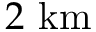<formula> <loc_0><loc_0><loc_500><loc_500>2 k m</formula> 